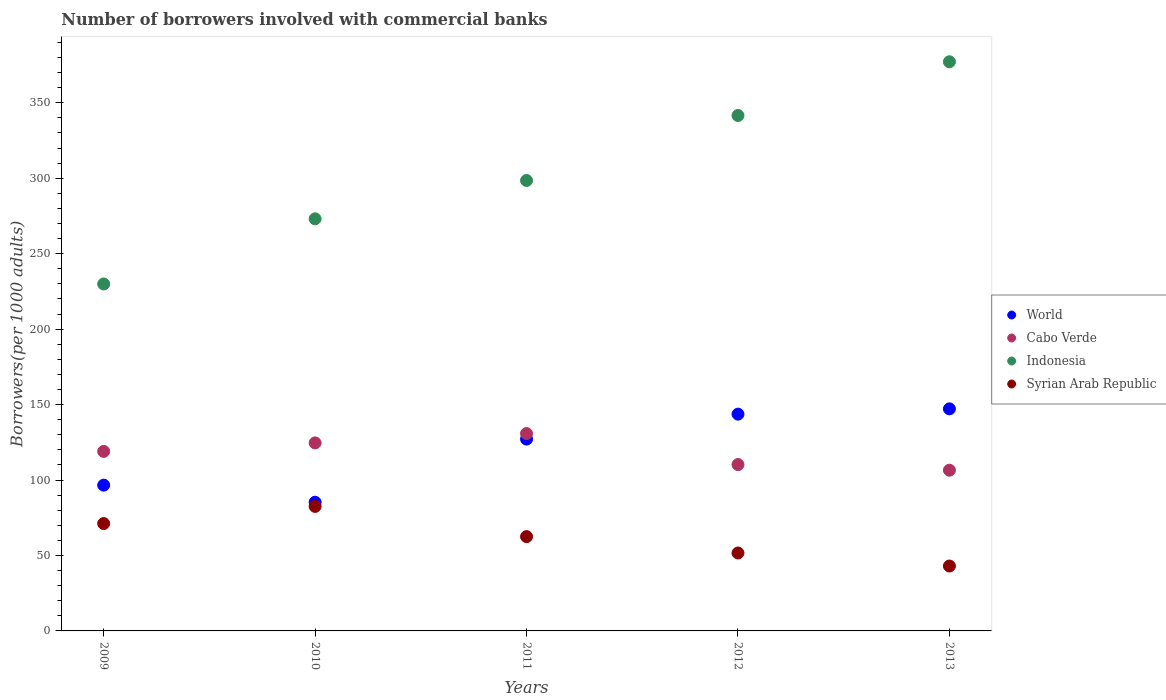How many different coloured dotlines are there?
Offer a terse response. 4. Is the number of dotlines equal to the number of legend labels?
Offer a very short reply. Yes. What is the number of borrowers involved with commercial banks in Syrian Arab Republic in 2011?
Provide a succinct answer. 62.5. Across all years, what is the maximum number of borrowers involved with commercial banks in Indonesia?
Your answer should be very brief. 377.16. Across all years, what is the minimum number of borrowers involved with commercial banks in World?
Ensure brevity in your answer.  85.29. In which year was the number of borrowers involved with commercial banks in Syrian Arab Republic maximum?
Your answer should be compact. 2010. In which year was the number of borrowers involved with commercial banks in Syrian Arab Republic minimum?
Give a very brief answer. 2013. What is the total number of borrowers involved with commercial banks in World in the graph?
Keep it short and to the point. 599.87. What is the difference between the number of borrowers involved with commercial banks in Syrian Arab Republic in 2009 and that in 2013?
Offer a very short reply. 28.13. What is the difference between the number of borrowers involved with commercial banks in Cabo Verde in 2013 and the number of borrowers involved with commercial banks in Syrian Arab Republic in 2012?
Make the answer very short. 54.86. What is the average number of borrowers involved with commercial banks in Indonesia per year?
Ensure brevity in your answer.  304.05. In the year 2012, what is the difference between the number of borrowers involved with commercial banks in Indonesia and number of borrowers involved with commercial banks in World?
Your answer should be compact. 197.9. In how many years, is the number of borrowers involved with commercial banks in Cabo Verde greater than 130?
Provide a short and direct response. 1. What is the ratio of the number of borrowers involved with commercial banks in Cabo Verde in 2011 to that in 2012?
Provide a short and direct response. 1.19. What is the difference between the highest and the second highest number of borrowers involved with commercial banks in Indonesia?
Provide a succinct answer. 35.59. What is the difference between the highest and the lowest number of borrowers involved with commercial banks in Indonesia?
Offer a very short reply. 147.25. Is the sum of the number of borrowers involved with commercial banks in World in 2012 and 2013 greater than the maximum number of borrowers involved with commercial banks in Indonesia across all years?
Give a very brief answer. No. Is it the case that in every year, the sum of the number of borrowers involved with commercial banks in Cabo Verde and number of borrowers involved with commercial banks in Indonesia  is greater than the sum of number of borrowers involved with commercial banks in Syrian Arab Republic and number of borrowers involved with commercial banks in World?
Ensure brevity in your answer.  Yes. How many dotlines are there?
Give a very brief answer. 4. Does the graph contain grids?
Keep it short and to the point. No. Where does the legend appear in the graph?
Your response must be concise. Center right. What is the title of the graph?
Keep it short and to the point. Number of borrowers involved with commercial banks. Does "Lao PDR" appear as one of the legend labels in the graph?
Provide a succinct answer. No. What is the label or title of the X-axis?
Your answer should be very brief. Years. What is the label or title of the Y-axis?
Your answer should be very brief. Borrowers(per 1000 adults). What is the Borrowers(per 1000 adults) of World in 2009?
Your answer should be compact. 96.61. What is the Borrowers(per 1000 adults) in Cabo Verde in 2009?
Keep it short and to the point. 118.96. What is the Borrowers(per 1000 adults) of Indonesia in 2009?
Provide a succinct answer. 229.92. What is the Borrowers(per 1000 adults) of Syrian Arab Republic in 2009?
Ensure brevity in your answer.  71.15. What is the Borrowers(per 1000 adults) of World in 2010?
Make the answer very short. 85.29. What is the Borrowers(per 1000 adults) of Cabo Verde in 2010?
Give a very brief answer. 124.61. What is the Borrowers(per 1000 adults) in Indonesia in 2010?
Provide a short and direct response. 273.1. What is the Borrowers(per 1000 adults) of Syrian Arab Republic in 2010?
Your response must be concise. 82.52. What is the Borrowers(per 1000 adults) of World in 2011?
Offer a very short reply. 127.13. What is the Borrowers(per 1000 adults) of Cabo Verde in 2011?
Your answer should be compact. 130.78. What is the Borrowers(per 1000 adults) in Indonesia in 2011?
Provide a succinct answer. 298.51. What is the Borrowers(per 1000 adults) in Syrian Arab Republic in 2011?
Your answer should be compact. 62.5. What is the Borrowers(per 1000 adults) in World in 2012?
Your answer should be compact. 143.67. What is the Borrowers(per 1000 adults) in Cabo Verde in 2012?
Your answer should be very brief. 110.25. What is the Borrowers(per 1000 adults) in Indonesia in 2012?
Offer a terse response. 341.57. What is the Borrowers(per 1000 adults) of Syrian Arab Republic in 2012?
Your response must be concise. 51.65. What is the Borrowers(per 1000 adults) in World in 2013?
Offer a terse response. 147.17. What is the Borrowers(per 1000 adults) of Cabo Verde in 2013?
Your response must be concise. 106.51. What is the Borrowers(per 1000 adults) in Indonesia in 2013?
Make the answer very short. 377.16. What is the Borrowers(per 1000 adults) of Syrian Arab Republic in 2013?
Make the answer very short. 43.01. Across all years, what is the maximum Borrowers(per 1000 adults) in World?
Give a very brief answer. 147.17. Across all years, what is the maximum Borrowers(per 1000 adults) in Cabo Verde?
Your answer should be very brief. 130.78. Across all years, what is the maximum Borrowers(per 1000 adults) of Indonesia?
Keep it short and to the point. 377.16. Across all years, what is the maximum Borrowers(per 1000 adults) of Syrian Arab Republic?
Your response must be concise. 82.52. Across all years, what is the minimum Borrowers(per 1000 adults) of World?
Your answer should be very brief. 85.29. Across all years, what is the minimum Borrowers(per 1000 adults) in Cabo Verde?
Keep it short and to the point. 106.51. Across all years, what is the minimum Borrowers(per 1000 adults) in Indonesia?
Your answer should be compact. 229.92. Across all years, what is the minimum Borrowers(per 1000 adults) of Syrian Arab Republic?
Offer a very short reply. 43.01. What is the total Borrowers(per 1000 adults) in World in the graph?
Keep it short and to the point. 599.87. What is the total Borrowers(per 1000 adults) in Cabo Verde in the graph?
Make the answer very short. 591.11. What is the total Borrowers(per 1000 adults) of Indonesia in the graph?
Your response must be concise. 1520.25. What is the total Borrowers(per 1000 adults) of Syrian Arab Republic in the graph?
Give a very brief answer. 310.82. What is the difference between the Borrowers(per 1000 adults) of World in 2009 and that in 2010?
Your response must be concise. 11.32. What is the difference between the Borrowers(per 1000 adults) of Cabo Verde in 2009 and that in 2010?
Offer a very short reply. -5.65. What is the difference between the Borrowers(per 1000 adults) of Indonesia in 2009 and that in 2010?
Your response must be concise. -43.19. What is the difference between the Borrowers(per 1000 adults) in Syrian Arab Republic in 2009 and that in 2010?
Your answer should be compact. -11.37. What is the difference between the Borrowers(per 1000 adults) in World in 2009 and that in 2011?
Offer a very short reply. -30.52. What is the difference between the Borrowers(per 1000 adults) in Cabo Verde in 2009 and that in 2011?
Your answer should be very brief. -11.82. What is the difference between the Borrowers(per 1000 adults) in Indonesia in 2009 and that in 2011?
Make the answer very short. -68.59. What is the difference between the Borrowers(per 1000 adults) of Syrian Arab Republic in 2009 and that in 2011?
Your answer should be very brief. 8.65. What is the difference between the Borrowers(per 1000 adults) in World in 2009 and that in 2012?
Make the answer very short. -47.06. What is the difference between the Borrowers(per 1000 adults) in Cabo Verde in 2009 and that in 2012?
Make the answer very short. 8.71. What is the difference between the Borrowers(per 1000 adults) of Indonesia in 2009 and that in 2012?
Offer a very short reply. -111.65. What is the difference between the Borrowers(per 1000 adults) of Syrian Arab Republic in 2009 and that in 2012?
Provide a succinct answer. 19.5. What is the difference between the Borrowers(per 1000 adults) of World in 2009 and that in 2013?
Offer a very short reply. -50.57. What is the difference between the Borrowers(per 1000 adults) of Cabo Verde in 2009 and that in 2013?
Your answer should be compact. 12.45. What is the difference between the Borrowers(per 1000 adults) of Indonesia in 2009 and that in 2013?
Your response must be concise. -147.25. What is the difference between the Borrowers(per 1000 adults) of Syrian Arab Republic in 2009 and that in 2013?
Keep it short and to the point. 28.13. What is the difference between the Borrowers(per 1000 adults) in World in 2010 and that in 2011?
Your answer should be compact. -41.84. What is the difference between the Borrowers(per 1000 adults) in Cabo Verde in 2010 and that in 2011?
Provide a short and direct response. -6.18. What is the difference between the Borrowers(per 1000 adults) of Indonesia in 2010 and that in 2011?
Give a very brief answer. -25.4. What is the difference between the Borrowers(per 1000 adults) of Syrian Arab Republic in 2010 and that in 2011?
Give a very brief answer. 20.02. What is the difference between the Borrowers(per 1000 adults) in World in 2010 and that in 2012?
Give a very brief answer. -58.38. What is the difference between the Borrowers(per 1000 adults) in Cabo Verde in 2010 and that in 2012?
Provide a succinct answer. 14.36. What is the difference between the Borrowers(per 1000 adults) of Indonesia in 2010 and that in 2012?
Provide a short and direct response. -68.47. What is the difference between the Borrowers(per 1000 adults) in Syrian Arab Republic in 2010 and that in 2012?
Your answer should be compact. 30.87. What is the difference between the Borrowers(per 1000 adults) of World in 2010 and that in 2013?
Offer a very short reply. -61.89. What is the difference between the Borrowers(per 1000 adults) in Cabo Verde in 2010 and that in 2013?
Give a very brief answer. 18.1. What is the difference between the Borrowers(per 1000 adults) in Indonesia in 2010 and that in 2013?
Your answer should be very brief. -104.06. What is the difference between the Borrowers(per 1000 adults) of Syrian Arab Republic in 2010 and that in 2013?
Provide a short and direct response. 39.51. What is the difference between the Borrowers(per 1000 adults) of World in 2011 and that in 2012?
Your answer should be very brief. -16.54. What is the difference between the Borrowers(per 1000 adults) of Cabo Verde in 2011 and that in 2012?
Offer a very short reply. 20.53. What is the difference between the Borrowers(per 1000 adults) of Indonesia in 2011 and that in 2012?
Provide a succinct answer. -43.06. What is the difference between the Borrowers(per 1000 adults) in Syrian Arab Republic in 2011 and that in 2012?
Offer a very short reply. 10.85. What is the difference between the Borrowers(per 1000 adults) of World in 2011 and that in 2013?
Ensure brevity in your answer.  -20.04. What is the difference between the Borrowers(per 1000 adults) in Cabo Verde in 2011 and that in 2013?
Keep it short and to the point. 24.27. What is the difference between the Borrowers(per 1000 adults) of Indonesia in 2011 and that in 2013?
Your answer should be very brief. -78.66. What is the difference between the Borrowers(per 1000 adults) of Syrian Arab Republic in 2011 and that in 2013?
Give a very brief answer. 19.49. What is the difference between the Borrowers(per 1000 adults) in World in 2012 and that in 2013?
Provide a succinct answer. -3.51. What is the difference between the Borrowers(per 1000 adults) of Cabo Verde in 2012 and that in 2013?
Keep it short and to the point. 3.74. What is the difference between the Borrowers(per 1000 adults) of Indonesia in 2012 and that in 2013?
Your response must be concise. -35.59. What is the difference between the Borrowers(per 1000 adults) in Syrian Arab Republic in 2012 and that in 2013?
Offer a very short reply. 8.63. What is the difference between the Borrowers(per 1000 adults) of World in 2009 and the Borrowers(per 1000 adults) of Cabo Verde in 2010?
Your response must be concise. -28. What is the difference between the Borrowers(per 1000 adults) in World in 2009 and the Borrowers(per 1000 adults) in Indonesia in 2010?
Your answer should be very brief. -176.49. What is the difference between the Borrowers(per 1000 adults) of World in 2009 and the Borrowers(per 1000 adults) of Syrian Arab Republic in 2010?
Keep it short and to the point. 14.09. What is the difference between the Borrowers(per 1000 adults) in Cabo Verde in 2009 and the Borrowers(per 1000 adults) in Indonesia in 2010?
Make the answer very short. -154.14. What is the difference between the Borrowers(per 1000 adults) of Cabo Verde in 2009 and the Borrowers(per 1000 adults) of Syrian Arab Republic in 2010?
Your answer should be compact. 36.44. What is the difference between the Borrowers(per 1000 adults) of Indonesia in 2009 and the Borrowers(per 1000 adults) of Syrian Arab Republic in 2010?
Provide a short and direct response. 147.4. What is the difference between the Borrowers(per 1000 adults) of World in 2009 and the Borrowers(per 1000 adults) of Cabo Verde in 2011?
Give a very brief answer. -34.17. What is the difference between the Borrowers(per 1000 adults) in World in 2009 and the Borrowers(per 1000 adults) in Indonesia in 2011?
Your answer should be compact. -201.9. What is the difference between the Borrowers(per 1000 adults) of World in 2009 and the Borrowers(per 1000 adults) of Syrian Arab Republic in 2011?
Make the answer very short. 34.11. What is the difference between the Borrowers(per 1000 adults) of Cabo Verde in 2009 and the Borrowers(per 1000 adults) of Indonesia in 2011?
Your answer should be very brief. -179.55. What is the difference between the Borrowers(per 1000 adults) of Cabo Verde in 2009 and the Borrowers(per 1000 adults) of Syrian Arab Republic in 2011?
Keep it short and to the point. 56.46. What is the difference between the Borrowers(per 1000 adults) of Indonesia in 2009 and the Borrowers(per 1000 adults) of Syrian Arab Republic in 2011?
Ensure brevity in your answer.  167.42. What is the difference between the Borrowers(per 1000 adults) of World in 2009 and the Borrowers(per 1000 adults) of Cabo Verde in 2012?
Provide a succinct answer. -13.64. What is the difference between the Borrowers(per 1000 adults) of World in 2009 and the Borrowers(per 1000 adults) of Indonesia in 2012?
Provide a short and direct response. -244.96. What is the difference between the Borrowers(per 1000 adults) of World in 2009 and the Borrowers(per 1000 adults) of Syrian Arab Republic in 2012?
Your answer should be very brief. 44.96. What is the difference between the Borrowers(per 1000 adults) of Cabo Verde in 2009 and the Borrowers(per 1000 adults) of Indonesia in 2012?
Provide a short and direct response. -222.61. What is the difference between the Borrowers(per 1000 adults) of Cabo Verde in 2009 and the Borrowers(per 1000 adults) of Syrian Arab Republic in 2012?
Give a very brief answer. 67.31. What is the difference between the Borrowers(per 1000 adults) in Indonesia in 2009 and the Borrowers(per 1000 adults) in Syrian Arab Republic in 2012?
Provide a succinct answer. 178.27. What is the difference between the Borrowers(per 1000 adults) of World in 2009 and the Borrowers(per 1000 adults) of Cabo Verde in 2013?
Give a very brief answer. -9.9. What is the difference between the Borrowers(per 1000 adults) of World in 2009 and the Borrowers(per 1000 adults) of Indonesia in 2013?
Give a very brief answer. -280.55. What is the difference between the Borrowers(per 1000 adults) of World in 2009 and the Borrowers(per 1000 adults) of Syrian Arab Republic in 2013?
Offer a very short reply. 53.6. What is the difference between the Borrowers(per 1000 adults) in Cabo Verde in 2009 and the Borrowers(per 1000 adults) in Indonesia in 2013?
Provide a short and direct response. -258.2. What is the difference between the Borrowers(per 1000 adults) of Cabo Verde in 2009 and the Borrowers(per 1000 adults) of Syrian Arab Republic in 2013?
Your response must be concise. 75.95. What is the difference between the Borrowers(per 1000 adults) in Indonesia in 2009 and the Borrowers(per 1000 adults) in Syrian Arab Republic in 2013?
Provide a succinct answer. 186.9. What is the difference between the Borrowers(per 1000 adults) in World in 2010 and the Borrowers(per 1000 adults) in Cabo Verde in 2011?
Ensure brevity in your answer.  -45.5. What is the difference between the Borrowers(per 1000 adults) of World in 2010 and the Borrowers(per 1000 adults) of Indonesia in 2011?
Provide a short and direct response. -213.22. What is the difference between the Borrowers(per 1000 adults) of World in 2010 and the Borrowers(per 1000 adults) of Syrian Arab Republic in 2011?
Give a very brief answer. 22.79. What is the difference between the Borrowers(per 1000 adults) of Cabo Verde in 2010 and the Borrowers(per 1000 adults) of Indonesia in 2011?
Give a very brief answer. -173.9. What is the difference between the Borrowers(per 1000 adults) in Cabo Verde in 2010 and the Borrowers(per 1000 adults) in Syrian Arab Republic in 2011?
Offer a very short reply. 62.11. What is the difference between the Borrowers(per 1000 adults) of Indonesia in 2010 and the Borrowers(per 1000 adults) of Syrian Arab Republic in 2011?
Your answer should be very brief. 210.6. What is the difference between the Borrowers(per 1000 adults) of World in 2010 and the Borrowers(per 1000 adults) of Cabo Verde in 2012?
Give a very brief answer. -24.96. What is the difference between the Borrowers(per 1000 adults) in World in 2010 and the Borrowers(per 1000 adults) in Indonesia in 2012?
Your answer should be very brief. -256.28. What is the difference between the Borrowers(per 1000 adults) of World in 2010 and the Borrowers(per 1000 adults) of Syrian Arab Republic in 2012?
Make the answer very short. 33.64. What is the difference between the Borrowers(per 1000 adults) of Cabo Verde in 2010 and the Borrowers(per 1000 adults) of Indonesia in 2012?
Provide a succinct answer. -216.96. What is the difference between the Borrowers(per 1000 adults) in Cabo Verde in 2010 and the Borrowers(per 1000 adults) in Syrian Arab Republic in 2012?
Ensure brevity in your answer.  72.96. What is the difference between the Borrowers(per 1000 adults) of Indonesia in 2010 and the Borrowers(per 1000 adults) of Syrian Arab Republic in 2012?
Your response must be concise. 221.45. What is the difference between the Borrowers(per 1000 adults) of World in 2010 and the Borrowers(per 1000 adults) of Cabo Verde in 2013?
Keep it short and to the point. -21.22. What is the difference between the Borrowers(per 1000 adults) of World in 2010 and the Borrowers(per 1000 adults) of Indonesia in 2013?
Your response must be concise. -291.88. What is the difference between the Borrowers(per 1000 adults) of World in 2010 and the Borrowers(per 1000 adults) of Syrian Arab Republic in 2013?
Offer a terse response. 42.27. What is the difference between the Borrowers(per 1000 adults) of Cabo Verde in 2010 and the Borrowers(per 1000 adults) of Indonesia in 2013?
Your answer should be very brief. -252.55. What is the difference between the Borrowers(per 1000 adults) of Cabo Verde in 2010 and the Borrowers(per 1000 adults) of Syrian Arab Republic in 2013?
Offer a terse response. 81.6. What is the difference between the Borrowers(per 1000 adults) in Indonesia in 2010 and the Borrowers(per 1000 adults) in Syrian Arab Republic in 2013?
Your response must be concise. 230.09. What is the difference between the Borrowers(per 1000 adults) of World in 2011 and the Borrowers(per 1000 adults) of Cabo Verde in 2012?
Your answer should be very brief. 16.88. What is the difference between the Borrowers(per 1000 adults) in World in 2011 and the Borrowers(per 1000 adults) in Indonesia in 2012?
Make the answer very short. -214.44. What is the difference between the Borrowers(per 1000 adults) in World in 2011 and the Borrowers(per 1000 adults) in Syrian Arab Republic in 2012?
Your answer should be compact. 75.48. What is the difference between the Borrowers(per 1000 adults) in Cabo Verde in 2011 and the Borrowers(per 1000 adults) in Indonesia in 2012?
Your answer should be very brief. -210.79. What is the difference between the Borrowers(per 1000 adults) in Cabo Verde in 2011 and the Borrowers(per 1000 adults) in Syrian Arab Republic in 2012?
Provide a short and direct response. 79.14. What is the difference between the Borrowers(per 1000 adults) in Indonesia in 2011 and the Borrowers(per 1000 adults) in Syrian Arab Republic in 2012?
Offer a terse response. 246.86. What is the difference between the Borrowers(per 1000 adults) in World in 2011 and the Borrowers(per 1000 adults) in Cabo Verde in 2013?
Ensure brevity in your answer.  20.62. What is the difference between the Borrowers(per 1000 adults) in World in 2011 and the Borrowers(per 1000 adults) in Indonesia in 2013?
Your answer should be compact. -250.03. What is the difference between the Borrowers(per 1000 adults) of World in 2011 and the Borrowers(per 1000 adults) of Syrian Arab Republic in 2013?
Make the answer very short. 84.12. What is the difference between the Borrowers(per 1000 adults) in Cabo Verde in 2011 and the Borrowers(per 1000 adults) in Indonesia in 2013?
Provide a short and direct response. -246.38. What is the difference between the Borrowers(per 1000 adults) in Cabo Verde in 2011 and the Borrowers(per 1000 adults) in Syrian Arab Republic in 2013?
Your response must be concise. 87.77. What is the difference between the Borrowers(per 1000 adults) of Indonesia in 2011 and the Borrowers(per 1000 adults) of Syrian Arab Republic in 2013?
Your answer should be very brief. 255.49. What is the difference between the Borrowers(per 1000 adults) in World in 2012 and the Borrowers(per 1000 adults) in Cabo Verde in 2013?
Your answer should be compact. 37.16. What is the difference between the Borrowers(per 1000 adults) in World in 2012 and the Borrowers(per 1000 adults) in Indonesia in 2013?
Your answer should be very brief. -233.5. What is the difference between the Borrowers(per 1000 adults) in World in 2012 and the Borrowers(per 1000 adults) in Syrian Arab Republic in 2013?
Provide a succinct answer. 100.65. What is the difference between the Borrowers(per 1000 adults) of Cabo Verde in 2012 and the Borrowers(per 1000 adults) of Indonesia in 2013?
Offer a terse response. -266.91. What is the difference between the Borrowers(per 1000 adults) in Cabo Verde in 2012 and the Borrowers(per 1000 adults) in Syrian Arab Republic in 2013?
Your answer should be compact. 67.24. What is the difference between the Borrowers(per 1000 adults) of Indonesia in 2012 and the Borrowers(per 1000 adults) of Syrian Arab Republic in 2013?
Offer a terse response. 298.56. What is the average Borrowers(per 1000 adults) of World per year?
Provide a succinct answer. 119.97. What is the average Borrowers(per 1000 adults) of Cabo Verde per year?
Keep it short and to the point. 118.22. What is the average Borrowers(per 1000 adults) in Indonesia per year?
Provide a succinct answer. 304.05. What is the average Borrowers(per 1000 adults) in Syrian Arab Republic per year?
Your response must be concise. 62.16. In the year 2009, what is the difference between the Borrowers(per 1000 adults) of World and Borrowers(per 1000 adults) of Cabo Verde?
Keep it short and to the point. -22.35. In the year 2009, what is the difference between the Borrowers(per 1000 adults) in World and Borrowers(per 1000 adults) in Indonesia?
Offer a terse response. -133.31. In the year 2009, what is the difference between the Borrowers(per 1000 adults) of World and Borrowers(per 1000 adults) of Syrian Arab Republic?
Offer a very short reply. 25.46. In the year 2009, what is the difference between the Borrowers(per 1000 adults) in Cabo Verde and Borrowers(per 1000 adults) in Indonesia?
Keep it short and to the point. -110.96. In the year 2009, what is the difference between the Borrowers(per 1000 adults) in Cabo Verde and Borrowers(per 1000 adults) in Syrian Arab Republic?
Ensure brevity in your answer.  47.81. In the year 2009, what is the difference between the Borrowers(per 1000 adults) of Indonesia and Borrowers(per 1000 adults) of Syrian Arab Republic?
Provide a succinct answer. 158.77. In the year 2010, what is the difference between the Borrowers(per 1000 adults) in World and Borrowers(per 1000 adults) in Cabo Verde?
Provide a succinct answer. -39.32. In the year 2010, what is the difference between the Borrowers(per 1000 adults) in World and Borrowers(per 1000 adults) in Indonesia?
Provide a short and direct response. -187.81. In the year 2010, what is the difference between the Borrowers(per 1000 adults) of World and Borrowers(per 1000 adults) of Syrian Arab Republic?
Provide a succinct answer. 2.77. In the year 2010, what is the difference between the Borrowers(per 1000 adults) in Cabo Verde and Borrowers(per 1000 adults) in Indonesia?
Your answer should be compact. -148.49. In the year 2010, what is the difference between the Borrowers(per 1000 adults) in Cabo Verde and Borrowers(per 1000 adults) in Syrian Arab Republic?
Offer a very short reply. 42.09. In the year 2010, what is the difference between the Borrowers(per 1000 adults) in Indonesia and Borrowers(per 1000 adults) in Syrian Arab Republic?
Offer a terse response. 190.58. In the year 2011, what is the difference between the Borrowers(per 1000 adults) of World and Borrowers(per 1000 adults) of Cabo Verde?
Provide a short and direct response. -3.65. In the year 2011, what is the difference between the Borrowers(per 1000 adults) in World and Borrowers(per 1000 adults) in Indonesia?
Give a very brief answer. -171.38. In the year 2011, what is the difference between the Borrowers(per 1000 adults) of World and Borrowers(per 1000 adults) of Syrian Arab Republic?
Give a very brief answer. 64.63. In the year 2011, what is the difference between the Borrowers(per 1000 adults) of Cabo Verde and Borrowers(per 1000 adults) of Indonesia?
Provide a short and direct response. -167.72. In the year 2011, what is the difference between the Borrowers(per 1000 adults) in Cabo Verde and Borrowers(per 1000 adults) in Syrian Arab Republic?
Provide a short and direct response. 68.29. In the year 2011, what is the difference between the Borrowers(per 1000 adults) of Indonesia and Borrowers(per 1000 adults) of Syrian Arab Republic?
Offer a very short reply. 236.01. In the year 2012, what is the difference between the Borrowers(per 1000 adults) of World and Borrowers(per 1000 adults) of Cabo Verde?
Your answer should be compact. 33.42. In the year 2012, what is the difference between the Borrowers(per 1000 adults) of World and Borrowers(per 1000 adults) of Indonesia?
Provide a short and direct response. -197.9. In the year 2012, what is the difference between the Borrowers(per 1000 adults) in World and Borrowers(per 1000 adults) in Syrian Arab Republic?
Keep it short and to the point. 92.02. In the year 2012, what is the difference between the Borrowers(per 1000 adults) of Cabo Verde and Borrowers(per 1000 adults) of Indonesia?
Offer a terse response. -231.32. In the year 2012, what is the difference between the Borrowers(per 1000 adults) of Cabo Verde and Borrowers(per 1000 adults) of Syrian Arab Republic?
Offer a very short reply. 58.6. In the year 2012, what is the difference between the Borrowers(per 1000 adults) in Indonesia and Borrowers(per 1000 adults) in Syrian Arab Republic?
Your answer should be compact. 289.92. In the year 2013, what is the difference between the Borrowers(per 1000 adults) of World and Borrowers(per 1000 adults) of Cabo Verde?
Give a very brief answer. 40.67. In the year 2013, what is the difference between the Borrowers(per 1000 adults) of World and Borrowers(per 1000 adults) of Indonesia?
Give a very brief answer. -229.99. In the year 2013, what is the difference between the Borrowers(per 1000 adults) in World and Borrowers(per 1000 adults) in Syrian Arab Republic?
Make the answer very short. 104.16. In the year 2013, what is the difference between the Borrowers(per 1000 adults) of Cabo Verde and Borrowers(per 1000 adults) of Indonesia?
Offer a terse response. -270.65. In the year 2013, what is the difference between the Borrowers(per 1000 adults) of Cabo Verde and Borrowers(per 1000 adults) of Syrian Arab Republic?
Your answer should be compact. 63.5. In the year 2013, what is the difference between the Borrowers(per 1000 adults) of Indonesia and Borrowers(per 1000 adults) of Syrian Arab Republic?
Your answer should be compact. 334.15. What is the ratio of the Borrowers(per 1000 adults) in World in 2009 to that in 2010?
Provide a short and direct response. 1.13. What is the ratio of the Borrowers(per 1000 adults) in Cabo Verde in 2009 to that in 2010?
Keep it short and to the point. 0.95. What is the ratio of the Borrowers(per 1000 adults) in Indonesia in 2009 to that in 2010?
Your answer should be compact. 0.84. What is the ratio of the Borrowers(per 1000 adults) of Syrian Arab Republic in 2009 to that in 2010?
Offer a terse response. 0.86. What is the ratio of the Borrowers(per 1000 adults) of World in 2009 to that in 2011?
Give a very brief answer. 0.76. What is the ratio of the Borrowers(per 1000 adults) in Cabo Verde in 2009 to that in 2011?
Make the answer very short. 0.91. What is the ratio of the Borrowers(per 1000 adults) of Indonesia in 2009 to that in 2011?
Ensure brevity in your answer.  0.77. What is the ratio of the Borrowers(per 1000 adults) in Syrian Arab Republic in 2009 to that in 2011?
Ensure brevity in your answer.  1.14. What is the ratio of the Borrowers(per 1000 adults) of World in 2009 to that in 2012?
Provide a succinct answer. 0.67. What is the ratio of the Borrowers(per 1000 adults) of Cabo Verde in 2009 to that in 2012?
Keep it short and to the point. 1.08. What is the ratio of the Borrowers(per 1000 adults) of Indonesia in 2009 to that in 2012?
Ensure brevity in your answer.  0.67. What is the ratio of the Borrowers(per 1000 adults) in Syrian Arab Republic in 2009 to that in 2012?
Give a very brief answer. 1.38. What is the ratio of the Borrowers(per 1000 adults) of World in 2009 to that in 2013?
Make the answer very short. 0.66. What is the ratio of the Borrowers(per 1000 adults) of Cabo Verde in 2009 to that in 2013?
Your answer should be very brief. 1.12. What is the ratio of the Borrowers(per 1000 adults) of Indonesia in 2009 to that in 2013?
Give a very brief answer. 0.61. What is the ratio of the Borrowers(per 1000 adults) of Syrian Arab Republic in 2009 to that in 2013?
Keep it short and to the point. 1.65. What is the ratio of the Borrowers(per 1000 adults) in World in 2010 to that in 2011?
Provide a succinct answer. 0.67. What is the ratio of the Borrowers(per 1000 adults) in Cabo Verde in 2010 to that in 2011?
Give a very brief answer. 0.95. What is the ratio of the Borrowers(per 1000 adults) in Indonesia in 2010 to that in 2011?
Provide a short and direct response. 0.91. What is the ratio of the Borrowers(per 1000 adults) of Syrian Arab Republic in 2010 to that in 2011?
Ensure brevity in your answer.  1.32. What is the ratio of the Borrowers(per 1000 adults) in World in 2010 to that in 2012?
Give a very brief answer. 0.59. What is the ratio of the Borrowers(per 1000 adults) in Cabo Verde in 2010 to that in 2012?
Ensure brevity in your answer.  1.13. What is the ratio of the Borrowers(per 1000 adults) in Indonesia in 2010 to that in 2012?
Offer a terse response. 0.8. What is the ratio of the Borrowers(per 1000 adults) of Syrian Arab Republic in 2010 to that in 2012?
Provide a succinct answer. 1.6. What is the ratio of the Borrowers(per 1000 adults) in World in 2010 to that in 2013?
Provide a short and direct response. 0.58. What is the ratio of the Borrowers(per 1000 adults) of Cabo Verde in 2010 to that in 2013?
Your answer should be very brief. 1.17. What is the ratio of the Borrowers(per 1000 adults) of Indonesia in 2010 to that in 2013?
Offer a terse response. 0.72. What is the ratio of the Borrowers(per 1000 adults) of Syrian Arab Republic in 2010 to that in 2013?
Make the answer very short. 1.92. What is the ratio of the Borrowers(per 1000 adults) of World in 2011 to that in 2012?
Make the answer very short. 0.88. What is the ratio of the Borrowers(per 1000 adults) of Cabo Verde in 2011 to that in 2012?
Your answer should be very brief. 1.19. What is the ratio of the Borrowers(per 1000 adults) of Indonesia in 2011 to that in 2012?
Your response must be concise. 0.87. What is the ratio of the Borrowers(per 1000 adults) in Syrian Arab Republic in 2011 to that in 2012?
Keep it short and to the point. 1.21. What is the ratio of the Borrowers(per 1000 adults) of World in 2011 to that in 2013?
Provide a short and direct response. 0.86. What is the ratio of the Borrowers(per 1000 adults) in Cabo Verde in 2011 to that in 2013?
Provide a short and direct response. 1.23. What is the ratio of the Borrowers(per 1000 adults) of Indonesia in 2011 to that in 2013?
Offer a terse response. 0.79. What is the ratio of the Borrowers(per 1000 adults) of Syrian Arab Republic in 2011 to that in 2013?
Ensure brevity in your answer.  1.45. What is the ratio of the Borrowers(per 1000 adults) of World in 2012 to that in 2013?
Your answer should be compact. 0.98. What is the ratio of the Borrowers(per 1000 adults) in Cabo Verde in 2012 to that in 2013?
Your answer should be very brief. 1.04. What is the ratio of the Borrowers(per 1000 adults) of Indonesia in 2012 to that in 2013?
Provide a short and direct response. 0.91. What is the ratio of the Borrowers(per 1000 adults) of Syrian Arab Republic in 2012 to that in 2013?
Provide a short and direct response. 1.2. What is the difference between the highest and the second highest Borrowers(per 1000 adults) in World?
Provide a succinct answer. 3.51. What is the difference between the highest and the second highest Borrowers(per 1000 adults) in Cabo Verde?
Your response must be concise. 6.18. What is the difference between the highest and the second highest Borrowers(per 1000 adults) in Indonesia?
Your answer should be very brief. 35.59. What is the difference between the highest and the second highest Borrowers(per 1000 adults) of Syrian Arab Republic?
Provide a succinct answer. 11.37. What is the difference between the highest and the lowest Borrowers(per 1000 adults) in World?
Provide a succinct answer. 61.89. What is the difference between the highest and the lowest Borrowers(per 1000 adults) of Cabo Verde?
Give a very brief answer. 24.27. What is the difference between the highest and the lowest Borrowers(per 1000 adults) of Indonesia?
Give a very brief answer. 147.25. What is the difference between the highest and the lowest Borrowers(per 1000 adults) of Syrian Arab Republic?
Offer a terse response. 39.51. 